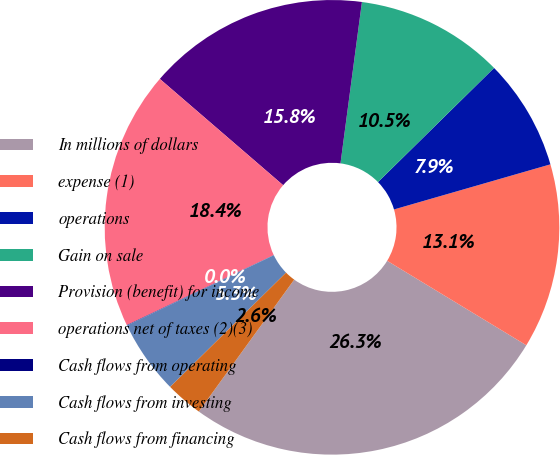Convert chart to OTSL. <chart><loc_0><loc_0><loc_500><loc_500><pie_chart><fcel>In millions of dollars<fcel>expense (1)<fcel>operations<fcel>Gain on sale<fcel>Provision (benefit) for income<fcel>operations net of taxes (2)(3)<fcel>Cash flows from operating<fcel>Cash flows from investing<fcel>Cash flows from financing<nl><fcel>26.28%<fcel>13.15%<fcel>7.9%<fcel>10.53%<fcel>15.78%<fcel>18.4%<fcel>0.03%<fcel>5.28%<fcel>2.65%<nl></chart> 